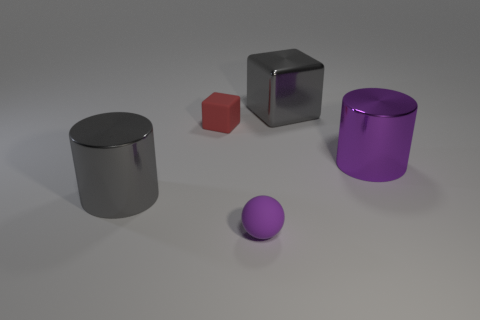Add 2 small blue rubber spheres. How many objects exist? 7 Subtract all gray cubes. How many cubes are left? 1 Subtract 1 cylinders. How many cylinders are left? 1 Subtract all red blocks. Subtract all blue cylinders. How many blocks are left? 1 Subtract all red spheres. How many green cylinders are left? 0 Subtract all purple metallic cylinders. Subtract all big purple cylinders. How many objects are left? 3 Add 5 tiny objects. How many tiny objects are left? 7 Add 5 large gray metal blocks. How many large gray metal blocks exist? 6 Subtract 0 yellow blocks. How many objects are left? 5 Subtract all balls. How many objects are left? 4 